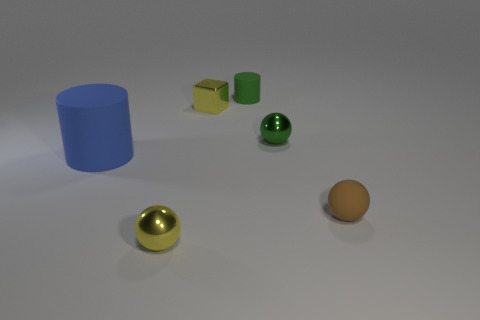Add 1 yellow shiny balls. How many objects exist? 7 Subtract all cubes. How many objects are left? 5 Subtract all small yellow metallic blocks. Subtract all large objects. How many objects are left? 4 Add 1 metallic spheres. How many metallic spheres are left? 3 Add 2 yellow metal things. How many yellow metal things exist? 4 Subtract 0 red spheres. How many objects are left? 6 